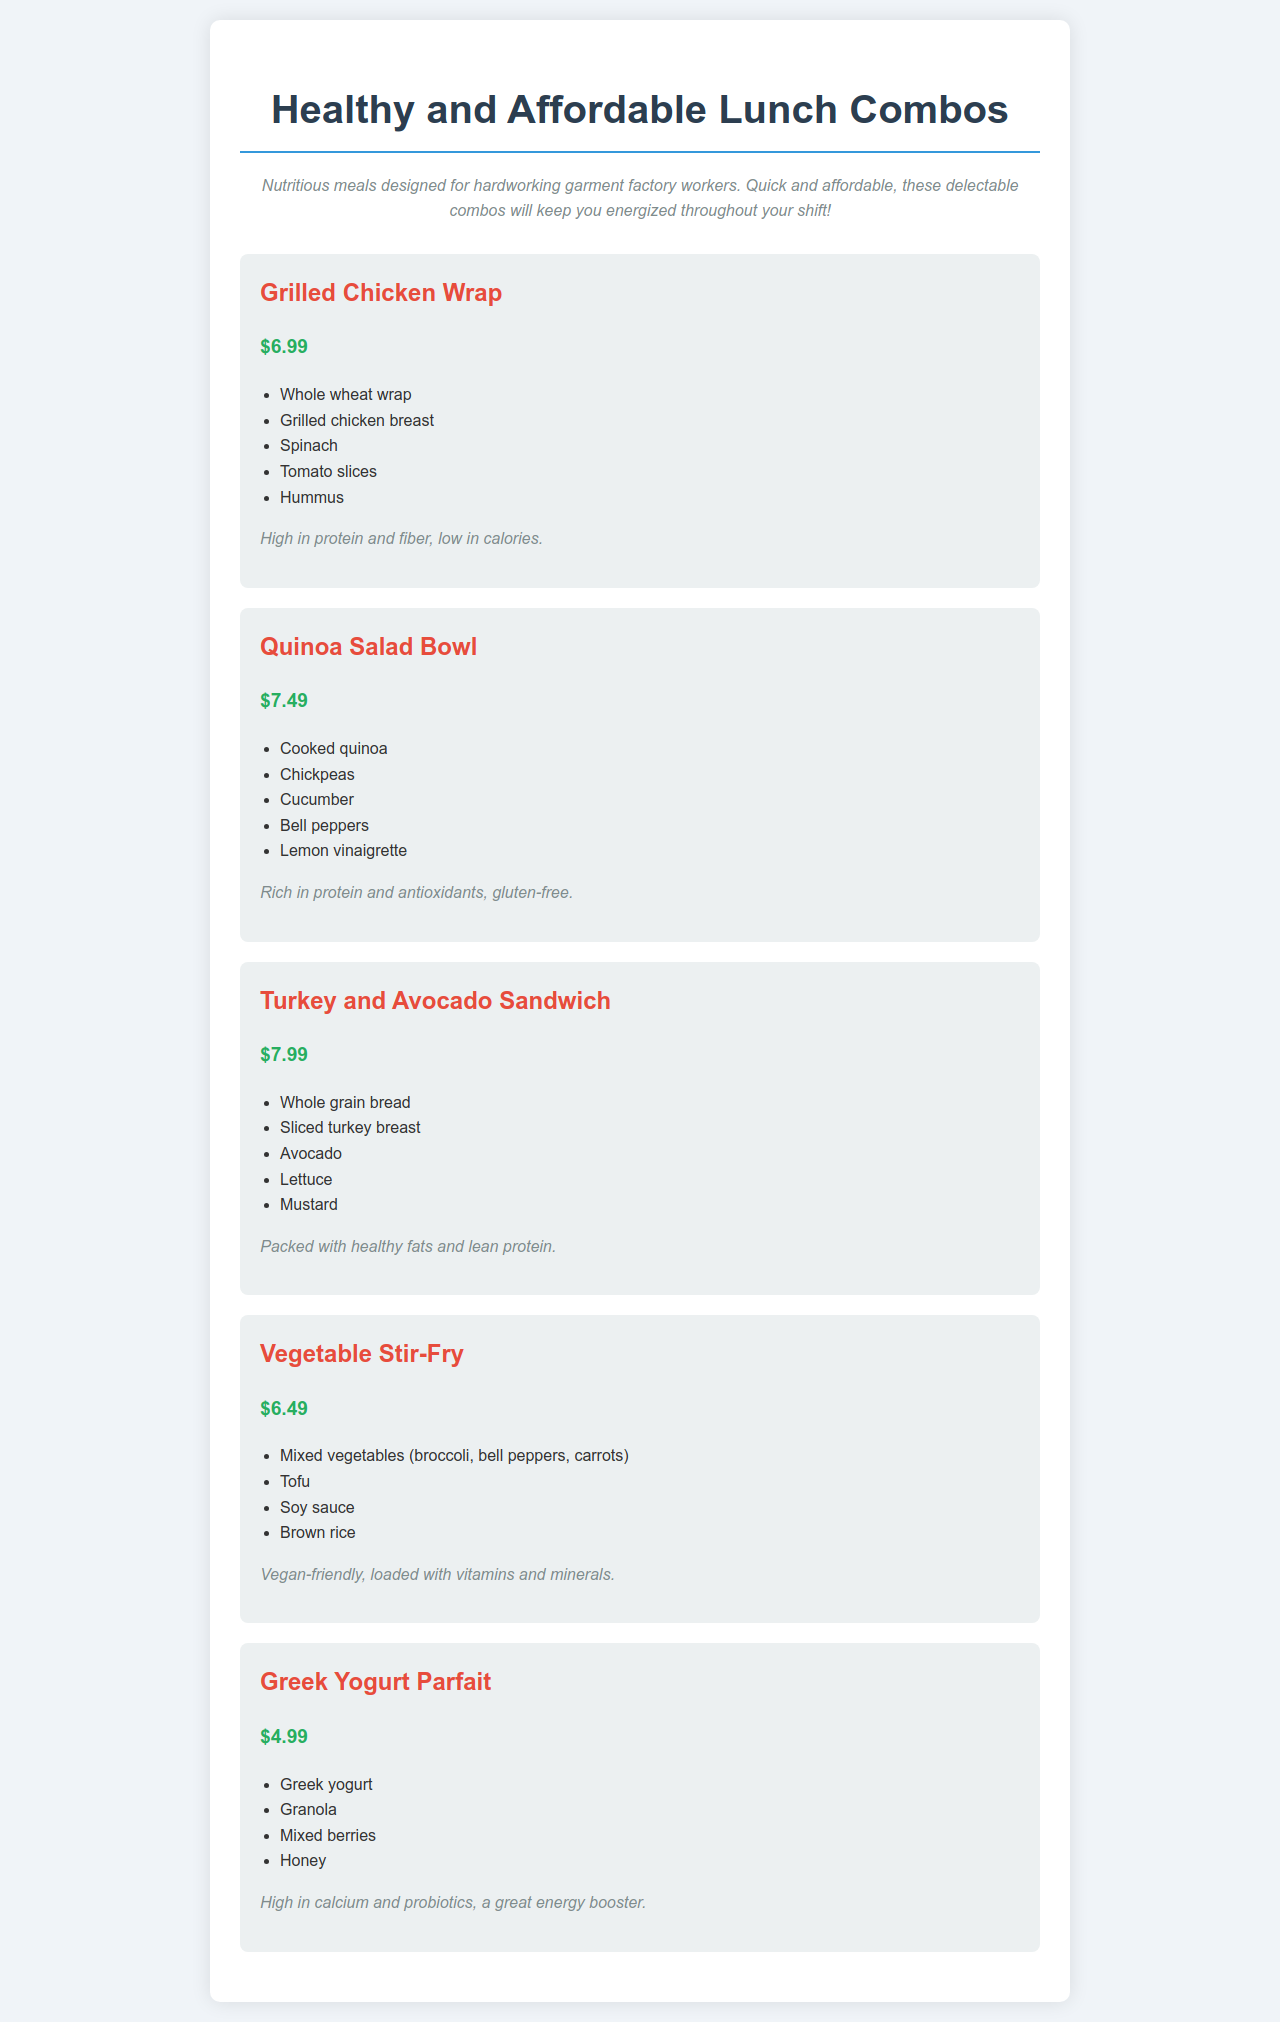what is the price of the Grilled Chicken Wrap? The price listed for the Grilled Chicken Wrap in the document is $6.99.
Answer: $6.99 how many items are in the Quinoa Salad Bowl? The Quinoa Salad Bowl includes five ingredients as listed in the document.
Answer: 5 what dietary option does the Vegetable Stir-Fry offer? The document specifies that the Vegetable Stir-Fry is vegan-friendly, indicating it caters to vegan diets.
Answer: Vegan-friendly which combo has the lowest price? The price of the Greek Yogurt Parfait is the lowest among the listed combos in the document.
Answer: $4.99 what is a primary nutritional benefit of the Turkey and Avocado Sandwich? The document states that the Turkey and Avocado Sandwich is packed with healthy fats and lean protein.
Answer: Healthy fats and lean protein how many combos are listed in total? The document provides a total of five different lunch combos for reference.
Answer: 5 what ingredient is common in all sandwiches? The sandwiches mentioned in the document include whole grain or whole wheat bread as a common ingredient.
Answer: Bread what is the main protein source in the Grilled Chicken Wrap? The main protein source identified in the Grilled Chicken Wrap is grilled chicken breast.
Answer: Grilled chicken breast 